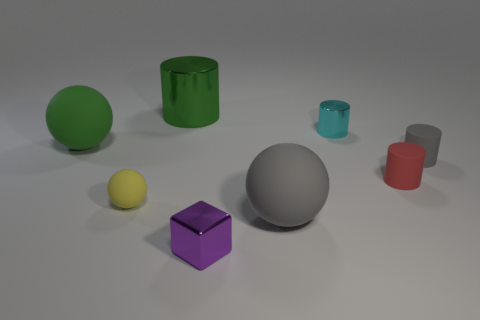Add 1 tiny things. How many objects exist? 9 Subtract all balls. How many objects are left? 5 Add 8 red matte cylinders. How many red matte cylinders exist? 9 Subtract 0 blue balls. How many objects are left? 8 Subtract all yellow things. Subtract all large gray balls. How many objects are left? 6 Add 1 tiny metallic blocks. How many tiny metallic blocks are left? 2 